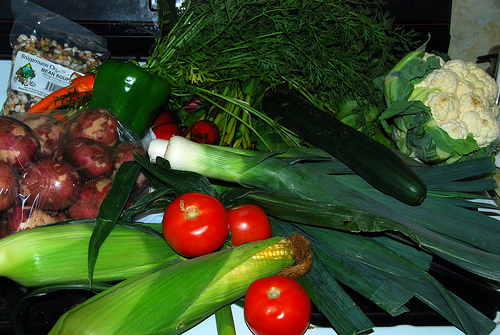<image>
Is the tomato on the corn? Yes. Looking at the image, I can see the tomato is positioned on top of the corn, with the corn providing support. 